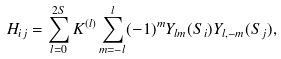<formula> <loc_0><loc_0><loc_500><loc_500>H _ { i j } = \sum _ { l = 0 } ^ { 2 S } K ^ { ( l ) } \sum _ { m = - l } ^ { l } ( - 1 ) ^ { m } Y _ { l m } ( { S } _ { i } ) Y _ { l , - m } ( { S } _ { j } ) ,</formula> 